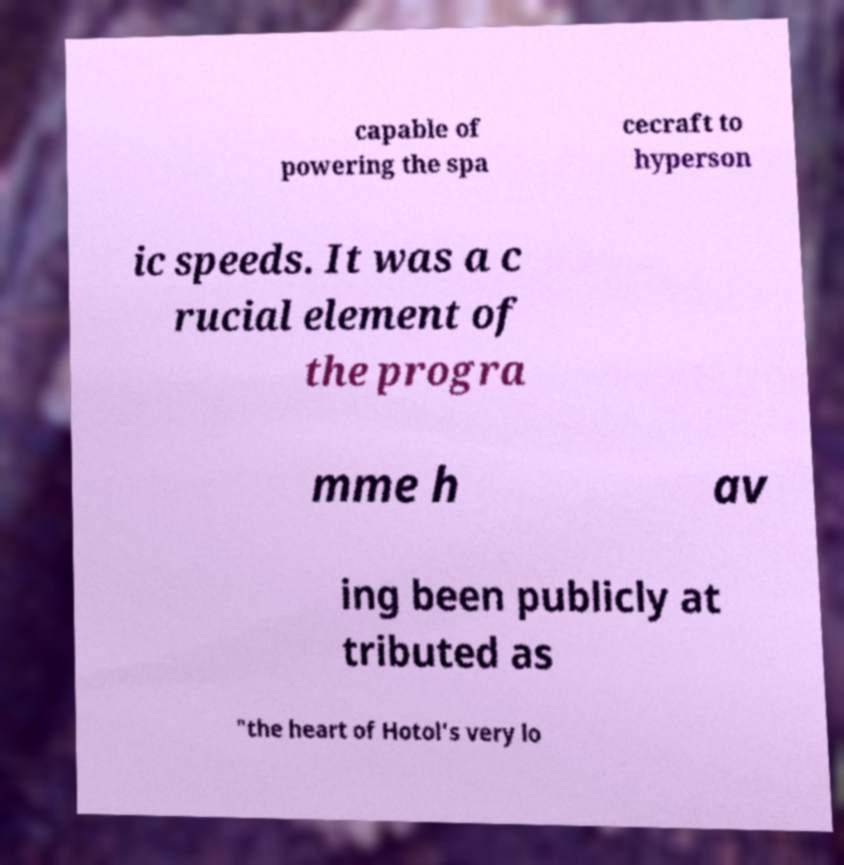Can you accurately transcribe the text from the provided image for me? capable of powering the spa cecraft to hyperson ic speeds. It was a c rucial element of the progra mme h av ing been publicly at tributed as "the heart of Hotol's very lo 